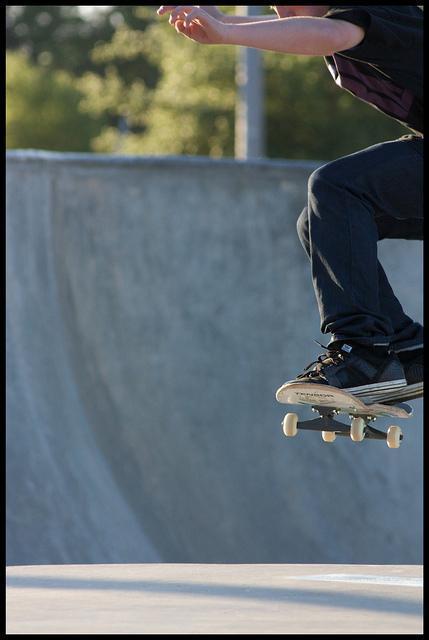How many wheels are on the skateboard?
Give a very brief answer. 4. 